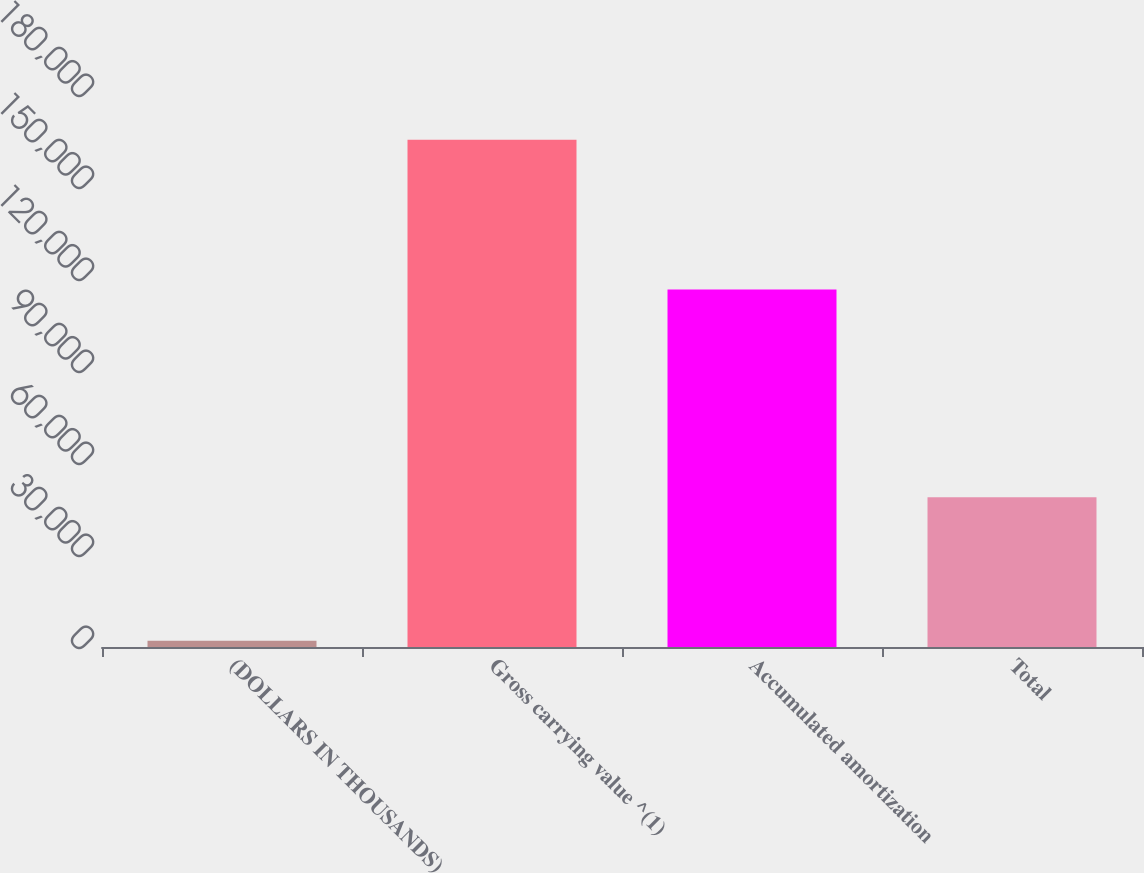Convert chart to OTSL. <chart><loc_0><loc_0><loc_500><loc_500><bar_chart><fcel>(DOLLARS IN THOUSANDS)<fcel>Gross carrying value ^(1)<fcel>Accumulated amortization<fcel>Total<nl><fcel>2010<fcel>165406<fcel>116572<fcel>48834<nl></chart> 